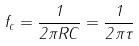<formula> <loc_0><loc_0><loc_500><loc_500>f _ { c } = \frac { 1 } { 2 \pi R C } = \frac { 1 } { 2 \pi \tau }</formula> 